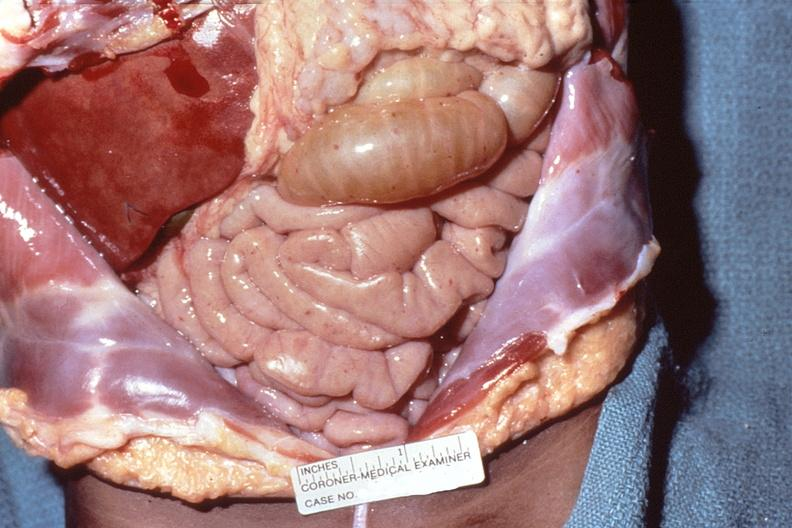does quite good liver show meningococcemia, petechia on serosal surface of abdominal viscera?
Answer the question using a single word or phrase. No 